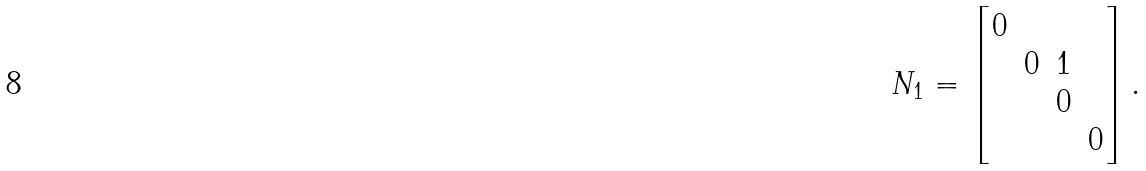<formula> <loc_0><loc_0><loc_500><loc_500>N _ { 1 } = \begin{bmatrix} 0 \\ & 0 & 1 \\ & & 0 \\ & & & 0 \end{bmatrix} .</formula> 